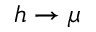Convert formula to latex. <formula><loc_0><loc_0><loc_500><loc_500>h \to \mu</formula> 